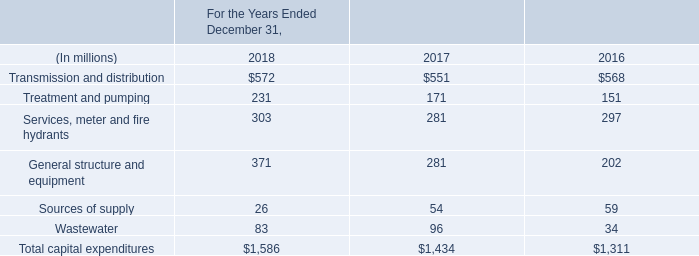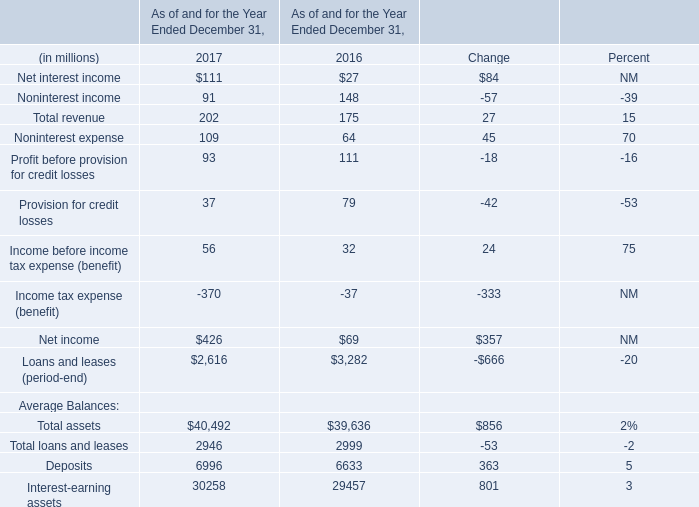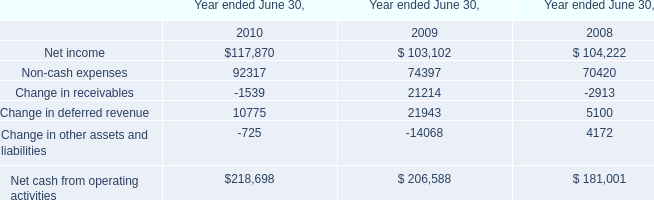Does Non-interest income keeps increasing each year between 2016and2017? 
Answer: No. 